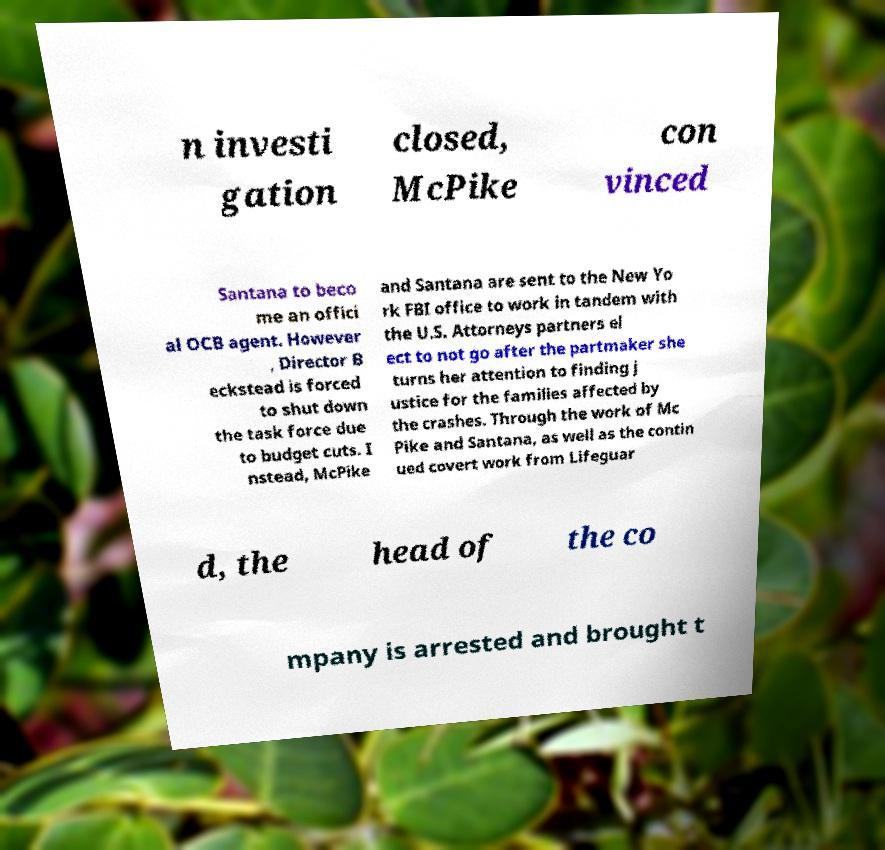Could you extract and type out the text from this image? n investi gation closed, McPike con vinced Santana to beco me an offici al OCB agent. However , Director B eckstead is forced to shut down the task force due to budget cuts. I nstead, McPike and Santana are sent to the New Yo rk FBI office to work in tandem with the U.S. Attorneys partners el ect to not go after the partmaker she turns her attention to finding j ustice for the families affected by the crashes. Through the work of Mc Pike and Santana, as well as the contin ued covert work from Lifeguar d, the head of the co mpany is arrested and brought t 